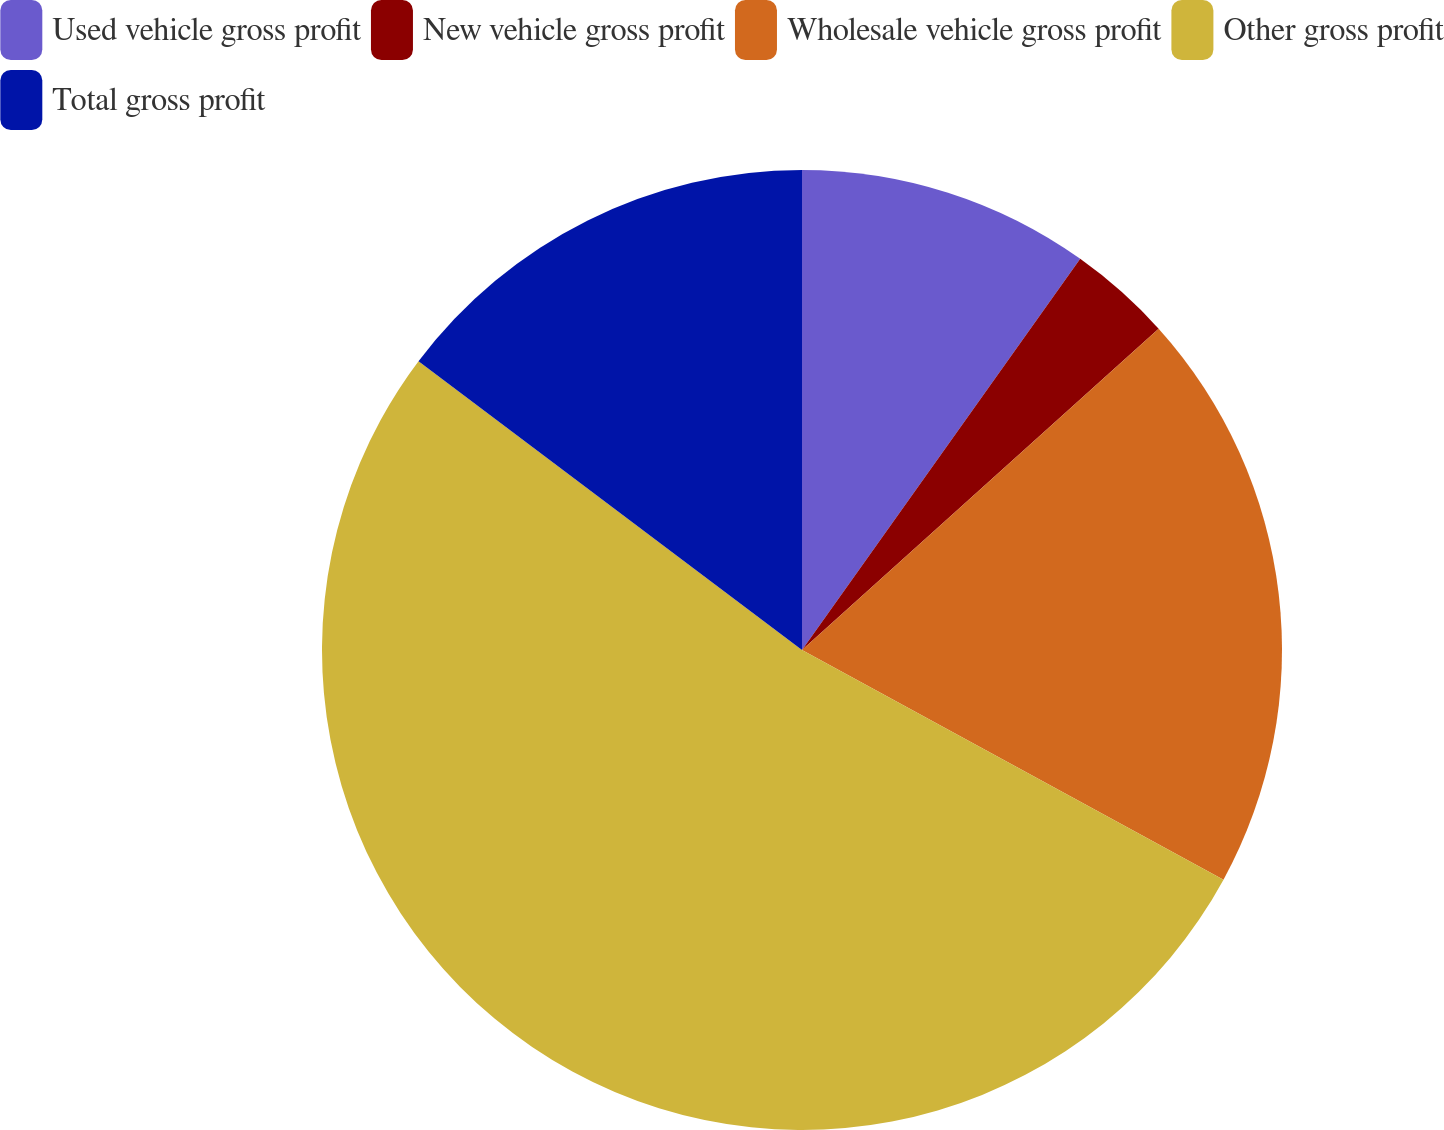Convert chart. <chart><loc_0><loc_0><loc_500><loc_500><pie_chart><fcel>Used vehicle gross profit<fcel>New vehicle gross profit<fcel>Wholesale vehicle gross profit<fcel>Other gross profit<fcel>Total gross profit<nl><fcel>9.84%<fcel>3.49%<fcel>19.61%<fcel>52.33%<fcel>14.73%<nl></chart> 